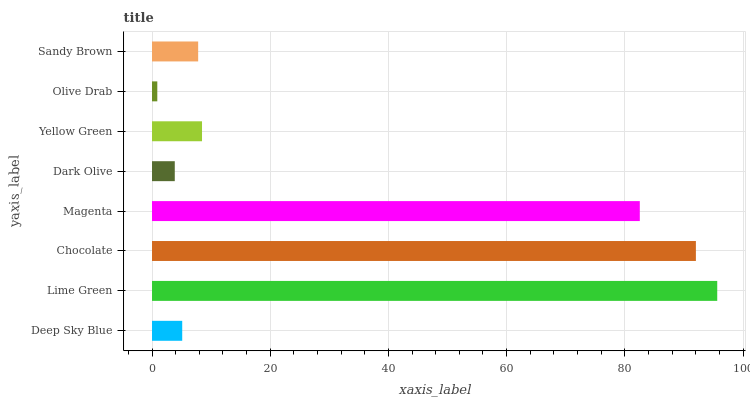Is Olive Drab the minimum?
Answer yes or no. Yes. Is Lime Green the maximum?
Answer yes or no. Yes. Is Chocolate the minimum?
Answer yes or no. No. Is Chocolate the maximum?
Answer yes or no. No. Is Lime Green greater than Chocolate?
Answer yes or no. Yes. Is Chocolate less than Lime Green?
Answer yes or no. Yes. Is Chocolate greater than Lime Green?
Answer yes or no. No. Is Lime Green less than Chocolate?
Answer yes or no. No. Is Yellow Green the high median?
Answer yes or no. Yes. Is Sandy Brown the low median?
Answer yes or no. Yes. Is Sandy Brown the high median?
Answer yes or no. No. Is Dark Olive the low median?
Answer yes or no. No. 